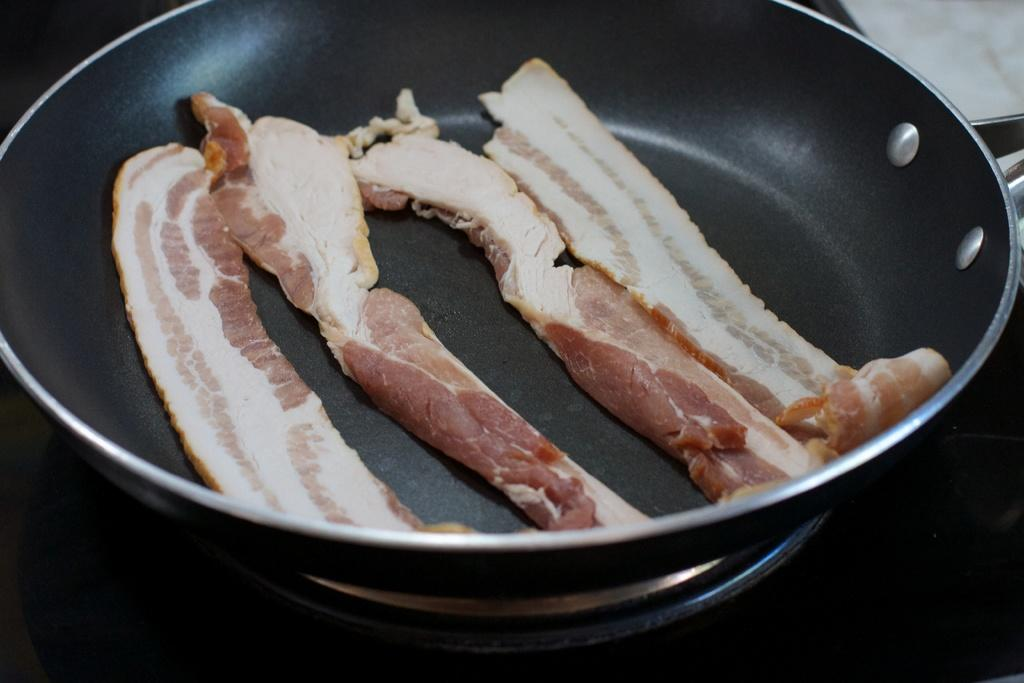What is the main object in the image? There is a pan in the image. What is happening with the pan in the image? There is meat being cooked in the pan. How much sugar is being used to cook the meat in the image? There is no sugar mentioned or visible in the image; the pan contains meat being cooked. 